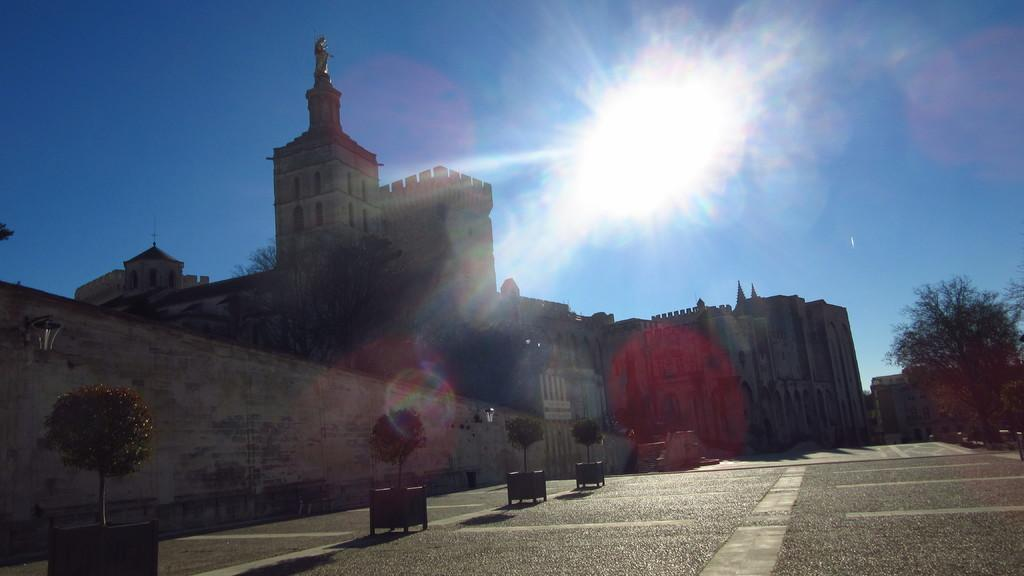What type of structures can be seen in the image? There are buildings in the image. Can you describe any specific features of the buildings? There is a statue on top of one of the buildings. What other elements can be seen in the image besides the buildings? There are trees in the image. What can be seen in the background of the image? The sky is visible in the background of the image. What is the lighting condition in the image? There is sunlight in the image. How does the orange wave in the image? There is no orange or wave present in the image. 